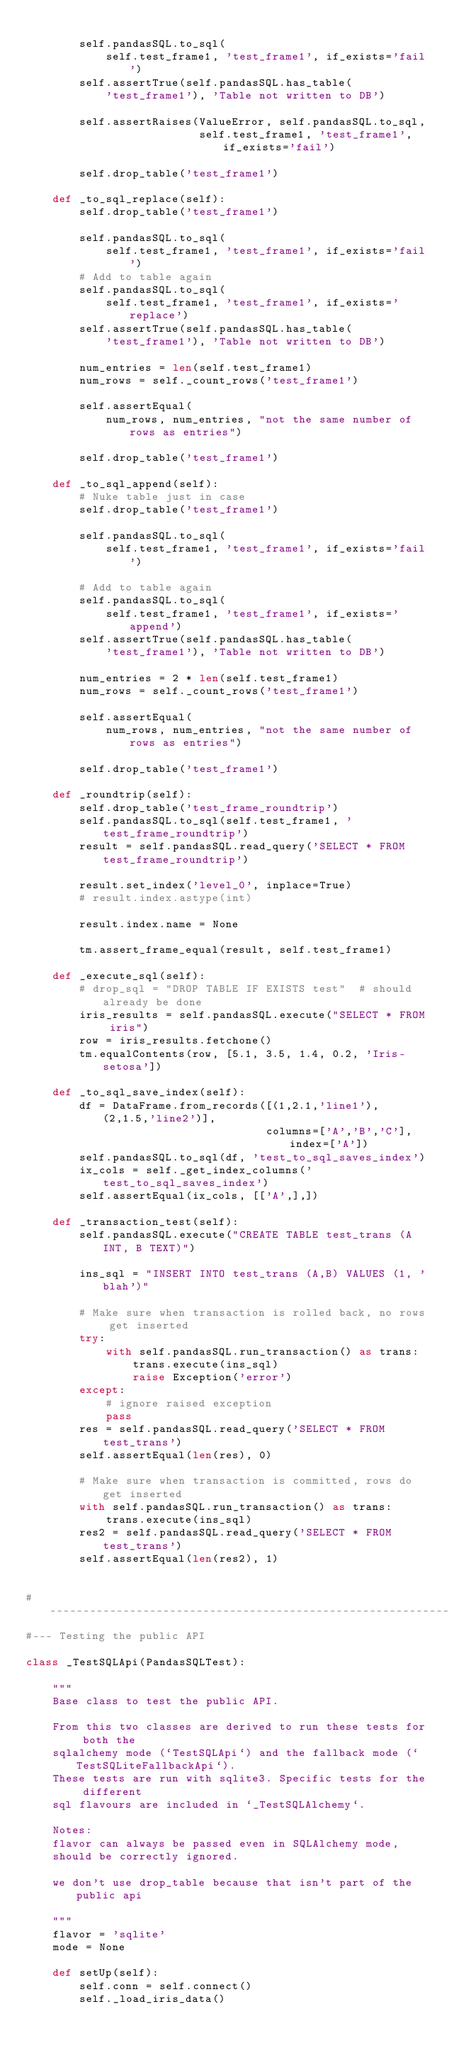Convert code to text. <code><loc_0><loc_0><loc_500><loc_500><_Python_>
        self.pandasSQL.to_sql(
            self.test_frame1, 'test_frame1', if_exists='fail')
        self.assertTrue(self.pandasSQL.has_table(
            'test_frame1'), 'Table not written to DB')

        self.assertRaises(ValueError, self.pandasSQL.to_sql,
                          self.test_frame1, 'test_frame1', if_exists='fail')

        self.drop_table('test_frame1')

    def _to_sql_replace(self):
        self.drop_table('test_frame1')

        self.pandasSQL.to_sql(
            self.test_frame1, 'test_frame1', if_exists='fail')
        # Add to table again
        self.pandasSQL.to_sql(
            self.test_frame1, 'test_frame1', if_exists='replace')
        self.assertTrue(self.pandasSQL.has_table(
            'test_frame1'), 'Table not written to DB')

        num_entries = len(self.test_frame1)
        num_rows = self._count_rows('test_frame1')

        self.assertEqual(
            num_rows, num_entries, "not the same number of rows as entries")

        self.drop_table('test_frame1')

    def _to_sql_append(self):
        # Nuke table just in case
        self.drop_table('test_frame1')

        self.pandasSQL.to_sql(
            self.test_frame1, 'test_frame1', if_exists='fail')

        # Add to table again
        self.pandasSQL.to_sql(
            self.test_frame1, 'test_frame1', if_exists='append')
        self.assertTrue(self.pandasSQL.has_table(
            'test_frame1'), 'Table not written to DB')

        num_entries = 2 * len(self.test_frame1)
        num_rows = self._count_rows('test_frame1')

        self.assertEqual(
            num_rows, num_entries, "not the same number of rows as entries")

        self.drop_table('test_frame1')

    def _roundtrip(self):
        self.drop_table('test_frame_roundtrip')
        self.pandasSQL.to_sql(self.test_frame1, 'test_frame_roundtrip')
        result = self.pandasSQL.read_query('SELECT * FROM test_frame_roundtrip')

        result.set_index('level_0', inplace=True)
        # result.index.astype(int)

        result.index.name = None

        tm.assert_frame_equal(result, self.test_frame1)

    def _execute_sql(self):
        # drop_sql = "DROP TABLE IF EXISTS test"  # should already be done
        iris_results = self.pandasSQL.execute("SELECT * FROM iris")
        row = iris_results.fetchone()
        tm.equalContents(row, [5.1, 3.5, 1.4, 0.2, 'Iris-setosa'])

    def _to_sql_save_index(self):
        df = DataFrame.from_records([(1,2.1,'line1'), (2,1.5,'line2')],
                                    columns=['A','B','C'], index=['A'])
        self.pandasSQL.to_sql(df, 'test_to_sql_saves_index')
        ix_cols = self._get_index_columns('test_to_sql_saves_index')
        self.assertEqual(ix_cols, [['A',],])

    def _transaction_test(self):
        self.pandasSQL.execute("CREATE TABLE test_trans (A INT, B TEXT)")

        ins_sql = "INSERT INTO test_trans (A,B) VALUES (1, 'blah')"

        # Make sure when transaction is rolled back, no rows get inserted
        try:
            with self.pandasSQL.run_transaction() as trans:
                trans.execute(ins_sql)
                raise Exception('error')
        except:
            # ignore raised exception
            pass
        res = self.pandasSQL.read_query('SELECT * FROM test_trans')
        self.assertEqual(len(res), 0)

        # Make sure when transaction is committed, rows do get inserted
        with self.pandasSQL.run_transaction() as trans:
            trans.execute(ins_sql)
        res2 = self.pandasSQL.read_query('SELECT * FROM test_trans')
        self.assertEqual(len(res2), 1)


#------------------------------------------------------------------------------
#--- Testing the public API

class _TestSQLApi(PandasSQLTest):

    """
    Base class to test the public API.

    From this two classes are derived to run these tests for both the
    sqlalchemy mode (`TestSQLApi`) and the fallback mode (`TestSQLiteFallbackApi`).
    These tests are run with sqlite3. Specific tests for the different
    sql flavours are included in `_TestSQLAlchemy`.

    Notes:
    flavor can always be passed even in SQLAlchemy mode,
    should be correctly ignored.

    we don't use drop_table because that isn't part of the public api

    """
    flavor = 'sqlite'
    mode = None

    def setUp(self):
        self.conn = self.connect()
        self._load_iris_data()</code> 